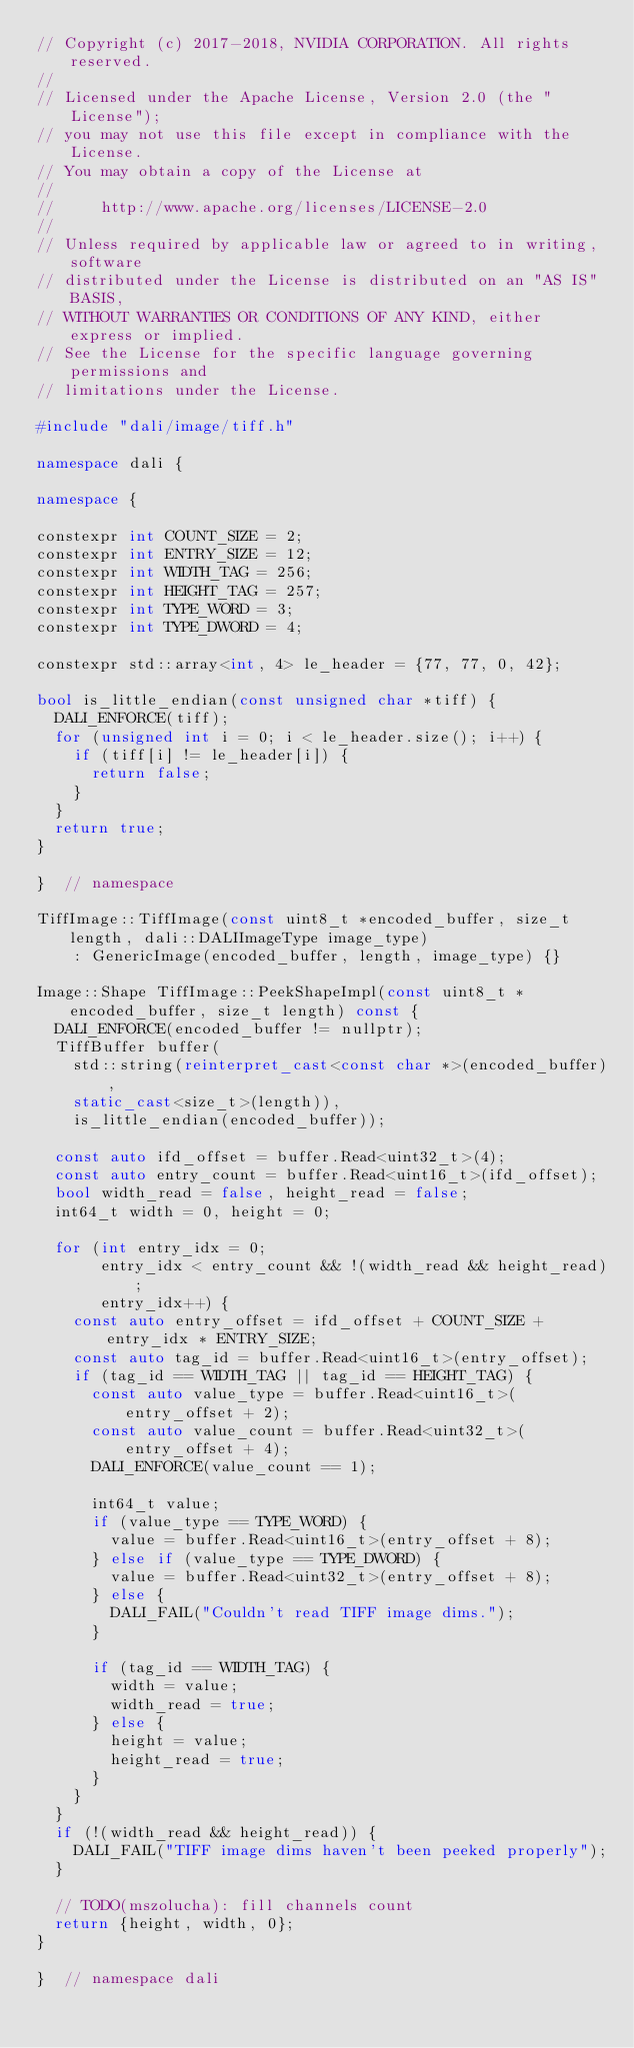<code> <loc_0><loc_0><loc_500><loc_500><_C++_>// Copyright (c) 2017-2018, NVIDIA CORPORATION. All rights reserved.
//
// Licensed under the Apache License, Version 2.0 (the "License");
// you may not use this file except in compliance with the License.
// You may obtain a copy of the License at
//
//     http://www.apache.org/licenses/LICENSE-2.0
//
// Unless required by applicable law or agreed to in writing, software
// distributed under the License is distributed on an "AS IS" BASIS,
// WITHOUT WARRANTIES OR CONDITIONS OF ANY KIND, either express or implied.
// See the License for the specific language governing permissions and
// limitations under the License.

#include "dali/image/tiff.h"

namespace dali {

namespace {

constexpr int COUNT_SIZE = 2;
constexpr int ENTRY_SIZE = 12;
constexpr int WIDTH_TAG = 256;
constexpr int HEIGHT_TAG = 257;
constexpr int TYPE_WORD = 3;
constexpr int TYPE_DWORD = 4;

constexpr std::array<int, 4> le_header = {77, 77, 0, 42};

bool is_little_endian(const unsigned char *tiff) {
  DALI_ENFORCE(tiff);
  for (unsigned int i = 0; i < le_header.size(); i++) {
    if (tiff[i] != le_header[i]) {
      return false;
    }
  }
  return true;
}

}  // namespace

TiffImage::TiffImage(const uint8_t *encoded_buffer, size_t length, dali::DALIImageType image_type)
    : GenericImage(encoded_buffer, length, image_type) {}

Image::Shape TiffImage::PeekShapeImpl(const uint8_t *encoded_buffer, size_t length) const {
  DALI_ENFORCE(encoded_buffer != nullptr);
  TiffBuffer buffer(
    std::string(reinterpret_cast<const char *>(encoded_buffer),
    static_cast<size_t>(length)),
    is_little_endian(encoded_buffer));

  const auto ifd_offset = buffer.Read<uint32_t>(4);
  const auto entry_count = buffer.Read<uint16_t>(ifd_offset);
  bool width_read = false, height_read = false;
  int64_t width = 0, height = 0;

  for (int entry_idx = 0;
       entry_idx < entry_count && !(width_read && height_read);
       entry_idx++) {
    const auto entry_offset = ifd_offset + COUNT_SIZE + entry_idx * ENTRY_SIZE;
    const auto tag_id = buffer.Read<uint16_t>(entry_offset);
    if (tag_id == WIDTH_TAG || tag_id == HEIGHT_TAG) {
      const auto value_type = buffer.Read<uint16_t>(entry_offset + 2);
      const auto value_count = buffer.Read<uint32_t>(entry_offset + 4);
      DALI_ENFORCE(value_count == 1);

      int64_t value;
      if (value_type == TYPE_WORD) {
        value = buffer.Read<uint16_t>(entry_offset + 8);
      } else if (value_type == TYPE_DWORD) {
        value = buffer.Read<uint32_t>(entry_offset + 8);
      } else {
        DALI_FAIL("Couldn't read TIFF image dims.");
      }

      if (tag_id == WIDTH_TAG) {
        width = value;
        width_read = true;
      } else {
        height = value;
        height_read = true;
      }
    }
  }
  if (!(width_read && height_read)) {
    DALI_FAIL("TIFF image dims haven't been peeked properly");
  }

  // TODO(mszolucha): fill channels count
  return {height, width, 0};
}

}  // namespace dali
</code> 